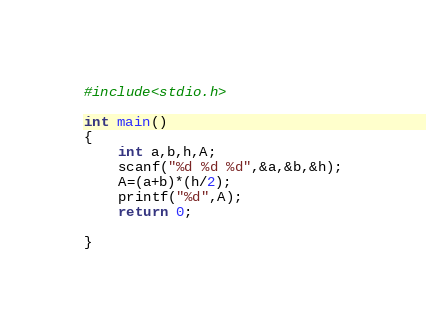<code> <loc_0><loc_0><loc_500><loc_500><_C_>
#include<stdio.h>

int main()
{
    int a,b,h,A;
    scanf("%d %d %d",&a,&b,&h);
    A=(a+b)*(h/2);
    printf("%d",A);
    return 0;

}





</code> 